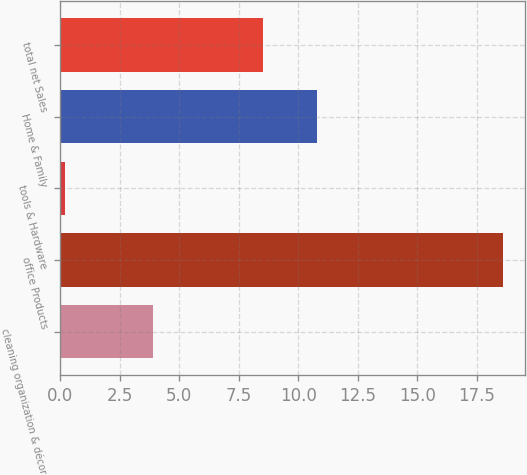<chart> <loc_0><loc_0><loc_500><loc_500><bar_chart><fcel>cleaning organization & décor<fcel>office Products<fcel>tools & Hardware<fcel>Home & Family<fcel>total net Sales<nl><fcel>3.9<fcel>18.6<fcel>0.2<fcel>10.8<fcel>8.5<nl></chart> 